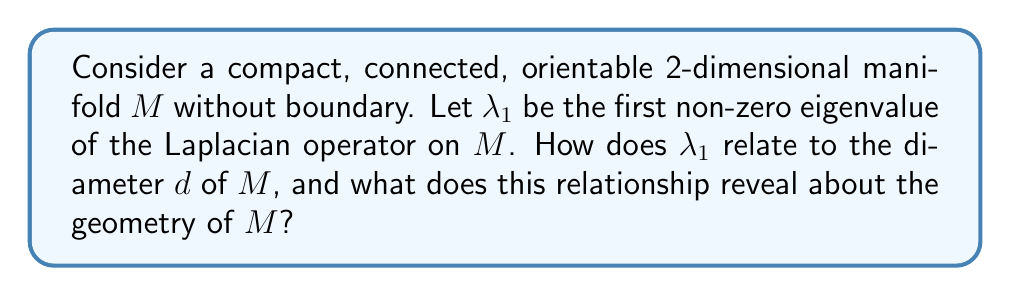Could you help me with this problem? To solve this problem, we'll follow these steps:

1) First, recall the Cheeger inequality for manifolds:

   $$\frac{\lambda_1}{4} \leq h(M)^2 \leq 2\lambda_1$$

   where $h(M)$ is the Cheeger constant of $M$.

2) The Cheeger constant $h(M)$ is related to the diameter $d$ of $M$ through the following inequality:

   $$h(M) \geq \frac{c}{d}$$

   where $c$ is a constant depending only on the dimension and geometry of $M$.

3) Combining these inequalities, we get:

   $$\frac{\lambda_1}{4} \leq \left(\frac{c}{d}\right)^2$$

4) Rearranging this inequality:

   $$\lambda_1 \leq \frac{4c^2}{d^2}$$

5) This inequality is known as Cheng's eigenvalue estimate.

6) The relationship $\lambda_1 \sim \frac{1}{d^2}$ tells us that as the diameter of $M$ increases, the first non-zero eigenvalue of the Laplacian decreases.

7) Geometrically, this means that manifolds with larger diameters (i.e., more "stretched out" manifolds) have smaller first non-zero eigenvalues.

8) Conversely, compact manifolds with high curvature (which tend to have smaller diameters) will have larger first non-zero eigenvalues.

9) This relationship demonstrates how the spectrum of the Laplacian (specifically, $\lambda_1$) encodes geometric information about the manifold (in this case, its "size" as measured by the diameter).
Answer: $\lambda_1 \leq \frac{4c^2}{d^2}$, where $c$ is a constant. This reveals that larger manifolds have smaller first non-zero eigenvalues, and vice versa. 